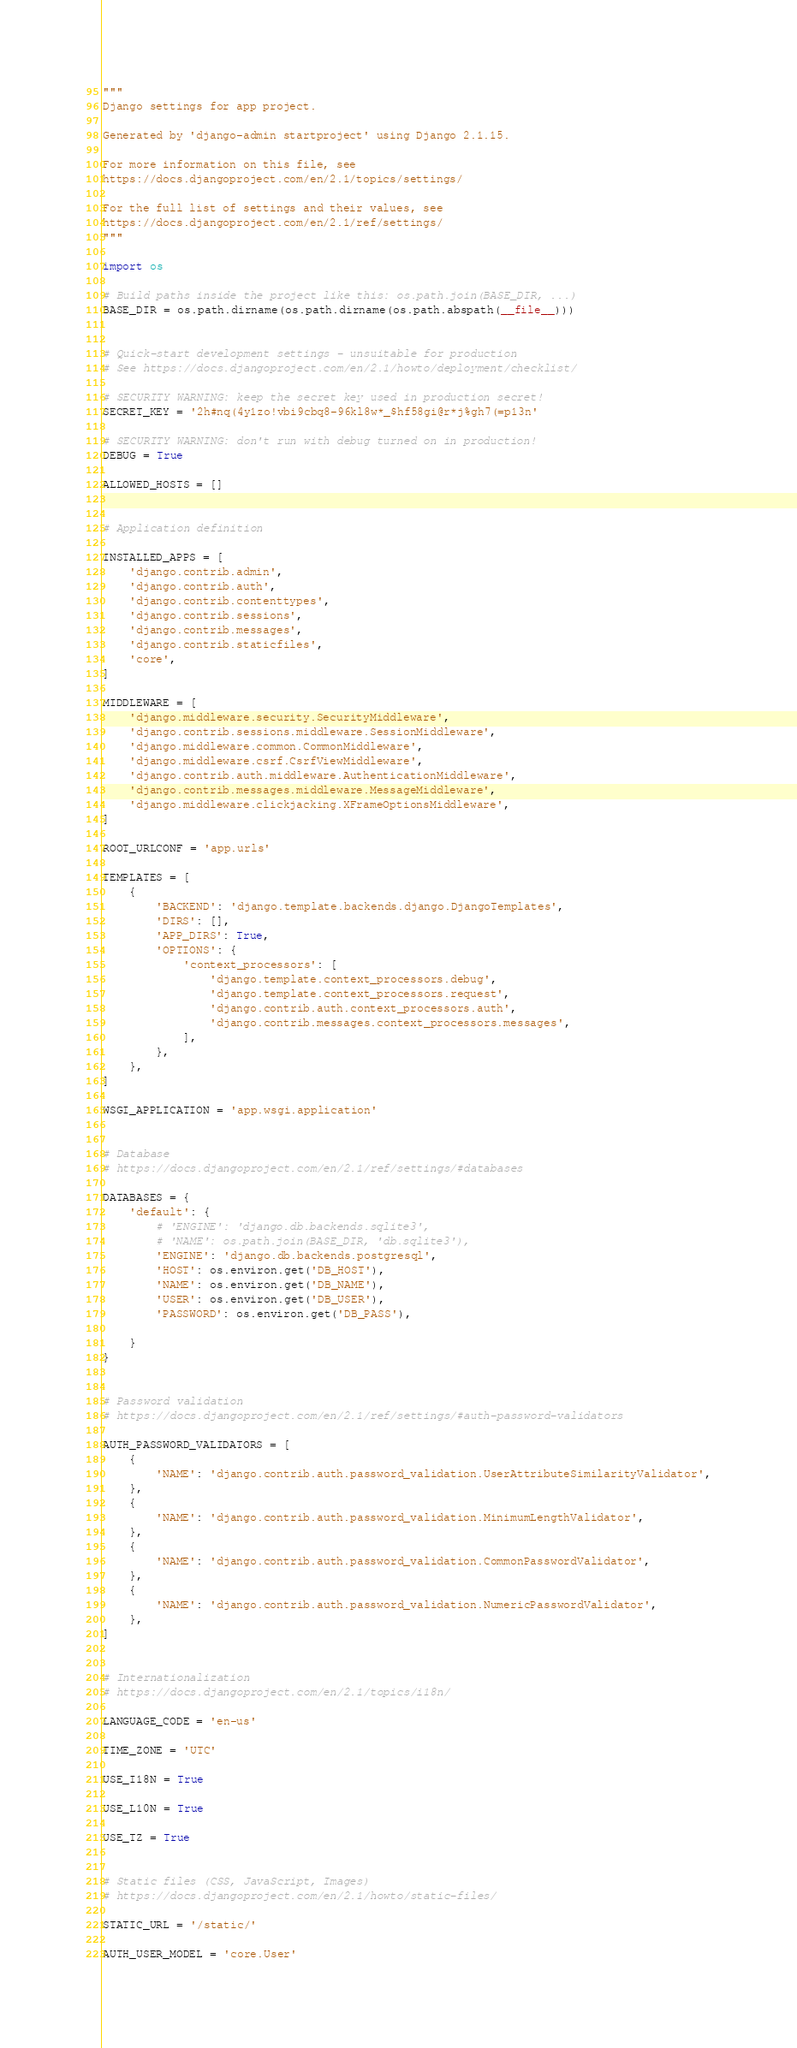Convert code to text. <code><loc_0><loc_0><loc_500><loc_500><_Python_>"""
Django settings for app project.

Generated by 'django-admin startproject' using Django 2.1.15.

For more information on this file, see
https://docs.djangoproject.com/en/2.1/topics/settings/

For the full list of settings and their values, see
https://docs.djangoproject.com/en/2.1/ref/settings/
"""

import os

# Build paths inside the project like this: os.path.join(BASE_DIR, ...)
BASE_DIR = os.path.dirname(os.path.dirname(os.path.abspath(__file__)))


# Quick-start development settings - unsuitable for production
# See https://docs.djangoproject.com/en/2.1/howto/deployment/checklist/

# SECURITY WARNING: keep the secret key used in production secret!
SECRET_KEY = '2h#nq(4y1zo!vbi9cbq8-96kl8w*_$hf58gi@r*j%gh7(=p13n'

# SECURITY WARNING: don't run with debug turned on in production!
DEBUG = True

ALLOWED_HOSTS = []


# Application definition

INSTALLED_APPS = [
    'django.contrib.admin',
    'django.contrib.auth',
    'django.contrib.contenttypes',
    'django.contrib.sessions',
    'django.contrib.messages',
    'django.contrib.staticfiles',
    'core',
]

MIDDLEWARE = [
    'django.middleware.security.SecurityMiddleware',
    'django.contrib.sessions.middleware.SessionMiddleware',
    'django.middleware.common.CommonMiddleware',
    'django.middleware.csrf.CsrfViewMiddleware',
    'django.contrib.auth.middleware.AuthenticationMiddleware',
    'django.contrib.messages.middleware.MessageMiddleware',
    'django.middleware.clickjacking.XFrameOptionsMiddleware',
]

ROOT_URLCONF = 'app.urls'

TEMPLATES = [
    {
        'BACKEND': 'django.template.backends.django.DjangoTemplates',
        'DIRS': [],
        'APP_DIRS': True,
        'OPTIONS': {
            'context_processors': [
                'django.template.context_processors.debug',
                'django.template.context_processors.request',
                'django.contrib.auth.context_processors.auth',
                'django.contrib.messages.context_processors.messages',
            ],
        },
    },
]

WSGI_APPLICATION = 'app.wsgi.application'


# Database
# https://docs.djangoproject.com/en/2.1/ref/settings/#databases

DATABASES = {
    'default': {
        # 'ENGINE': 'django.db.backends.sqlite3',
        # 'NAME': os.path.join(BASE_DIR, 'db.sqlite3'),
        'ENGINE': 'django.db.backends.postgresql',
        'HOST': os.environ.get('DB_HOST'),
        'NAME': os.environ.get('DB_NAME'),
        'USER': os.environ.get('DB_USER'),
        'PASSWORD': os.environ.get('DB_PASS'),

    }
}


# Password validation
# https://docs.djangoproject.com/en/2.1/ref/settings/#auth-password-validators

AUTH_PASSWORD_VALIDATORS = [
    {
        'NAME': 'django.contrib.auth.password_validation.UserAttributeSimilarityValidator',
    },
    {
        'NAME': 'django.contrib.auth.password_validation.MinimumLengthValidator',
    },
    {
        'NAME': 'django.contrib.auth.password_validation.CommonPasswordValidator',
    },
    {
        'NAME': 'django.contrib.auth.password_validation.NumericPasswordValidator',
    },
]


# Internationalization
# https://docs.djangoproject.com/en/2.1/topics/i18n/

LANGUAGE_CODE = 'en-us'

TIME_ZONE = 'UTC'

USE_I18N = True

USE_L10N = True

USE_TZ = True


# Static files (CSS, JavaScript, Images)
# https://docs.djangoproject.com/en/2.1/howto/static-files/

STATIC_URL = '/static/'

AUTH_USER_MODEL = 'core.User'
</code> 